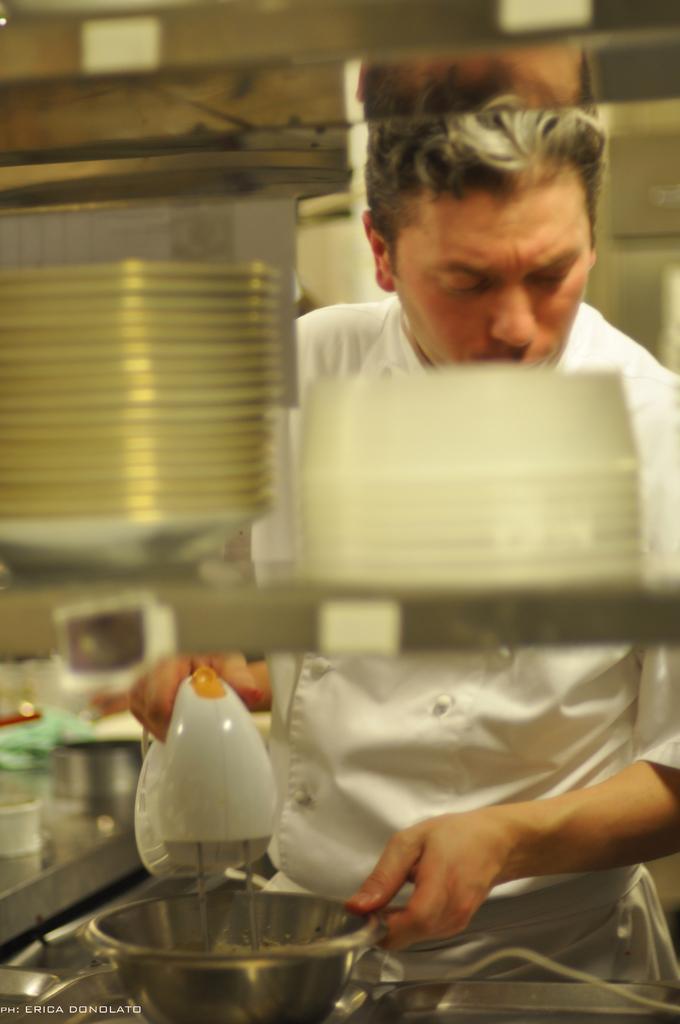In one or two sentences, can you explain what this image depicts? In this picture we can see a man standing and he is holding a cake blender and a bowl. We can see plates in the rack. We can see few objects. In the bottom left corner of the picture we can see watermark. 